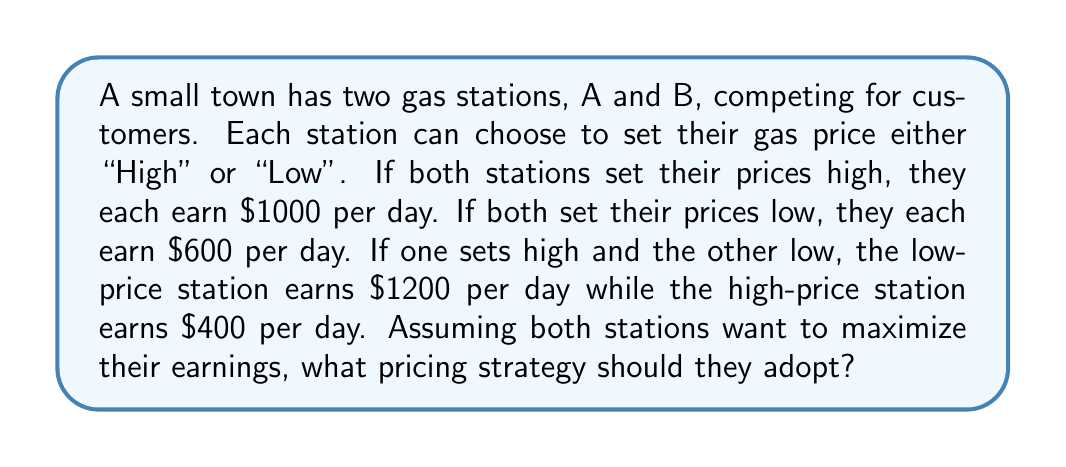Can you solve this math problem? To solve this problem, we'll use a basic concept from game theory called the Nash equilibrium. Here's how we can approach it:

1. First, let's set up a payoff matrix to visualize the situation:

$$
\begin{array}{c|c|c}
 & \text{B High} & \text{B Low} \\
\hline
\text{A High} & (1000, 1000) & (400, 1200) \\
\hline
\text{A Low} & (1200, 400) & (600, 600)
\end{array}
$$

2. In this matrix, the first number in each cell represents Station A's payoff, and the second number represents Station B's payoff.

3. To find the Nash equilibrium, we need to consider each station's best response to the other's strategy:

   - If B chooses High, A's best response is Low (1200 > 1000)
   - If B chooses Low, A's best response is Low (600 > 400)
   - If A chooses High, B's best response is Low (1200 > 1000)
   - If A chooses Low, B's best response is Low (600 > 400)

4. We can see that regardless of what the other station does, each station's best strategy is always to set a Low price.

5. This leads us to the Nash equilibrium, where both stations choose Low prices, resulting in each earning $600 per day.

6. This situation is also known as the Prisoner's Dilemma, where the Nash equilibrium (both choosing Low) is not the most beneficial outcome for either player. If they could cooperate and both choose High, they would each earn $1000, but the incentive to undercut the other always pushes them towards the Low strategy.

In real-world markets, this kind of competition often leads to price wars, where businesses continually lower prices to attract customers, potentially reducing profitability for all participants.
Answer: The Nash equilibrium strategy for both gas stations is to set their prices Low, resulting in each station earning $600 per day. 